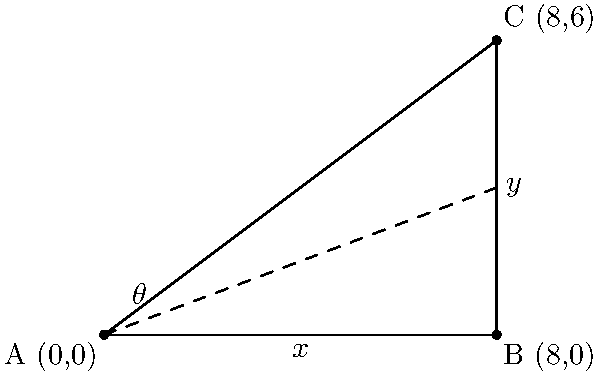As a pediatrician advising on BMX safety, you're consulting on the design of a ramp. The ramp is represented by a right triangle ABC on a coordinate plane, where A(0,0), B(8,0), and C(8,6). What is the angle θ (in degrees) between the ground and the ramp surface, which represents the safest inclination for beginner BMX riders? To find the angle θ, we can use the arctangent function, as it gives us the angle when we know the opposite and adjacent sides of a right triangle. Here's how we solve it step-by-step:

1) In the right triangle ABC, we need to find the angle at point A.

2) The opposite side (y-coordinate of point C) = 6
   The adjacent side (x-coordinate of point C) = 8

3) tan(θ) = opposite / adjacent
           = 6 / 8
           = 3 / 4

4) Therefore, θ = arctan(3/4)

5) Using a calculator or programming function:
   θ ≈ 36.87 degrees

6) Rounding to the nearest degree:
   θ ≈ 37 degrees

This angle of approximately 37 degrees provides a good balance between challenge and safety for beginner BMX riders, allowing them to practice their skills while minimizing the risk of severe falls.
Answer: 37 degrees 